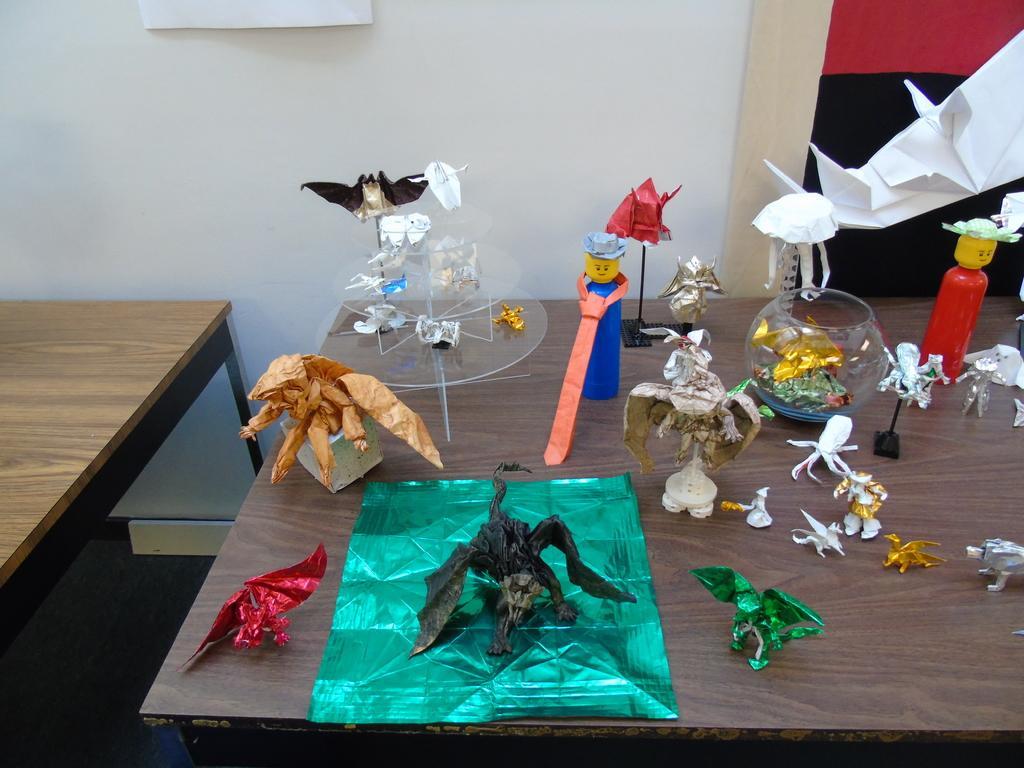How would you summarize this image in a sentence or two? In this picture we can see a wall ,an right to opposite there is a table on the floor, and many toys on it. 